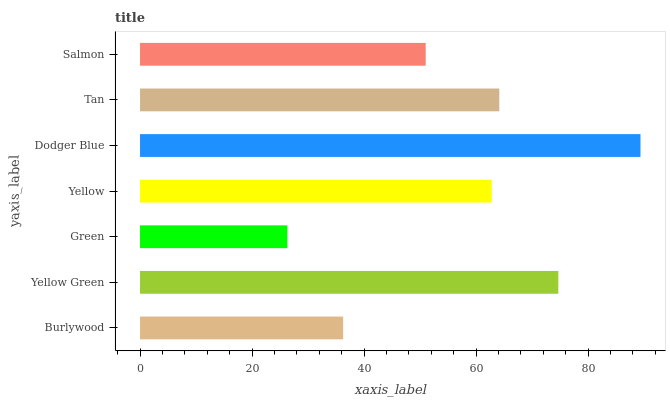Is Green the minimum?
Answer yes or no. Yes. Is Dodger Blue the maximum?
Answer yes or no. Yes. Is Yellow Green the minimum?
Answer yes or no. No. Is Yellow Green the maximum?
Answer yes or no. No. Is Yellow Green greater than Burlywood?
Answer yes or no. Yes. Is Burlywood less than Yellow Green?
Answer yes or no. Yes. Is Burlywood greater than Yellow Green?
Answer yes or no. No. Is Yellow Green less than Burlywood?
Answer yes or no. No. Is Yellow the high median?
Answer yes or no. Yes. Is Yellow the low median?
Answer yes or no. Yes. Is Burlywood the high median?
Answer yes or no. No. Is Salmon the low median?
Answer yes or no. No. 